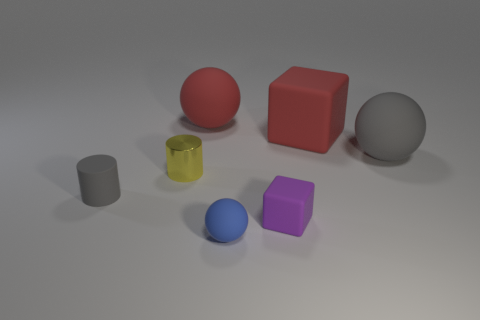Is there any other thing that has the same material as the yellow object?
Provide a succinct answer. No. The matte object that is the same shape as the yellow shiny object is what size?
Your answer should be very brief. Small. Are there fewer big gray things that are to the left of the small yellow cylinder than red spheres on the right side of the tiny cube?
Your answer should be very brief. No. What is the shape of the object that is both in front of the metallic cylinder and right of the tiny blue object?
Provide a short and direct response. Cube. What is the size of the other gray sphere that is the same material as the small ball?
Make the answer very short. Large. There is a large block; does it have the same color as the big matte ball to the left of the tiny purple thing?
Your response must be concise. Yes. What is the object that is both behind the rubber cylinder and in front of the gray rubber sphere made of?
Your answer should be very brief. Metal. Do the tiny matte object behind the small purple thing and the tiny thing behind the gray rubber cylinder have the same shape?
Ensure brevity in your answer.  Yes. Is there a small cube?
Your answer should be very brief. Yes. The big object that is the same shape as the tiny purple matte thing is what color?
Offer a terse response. Red. 